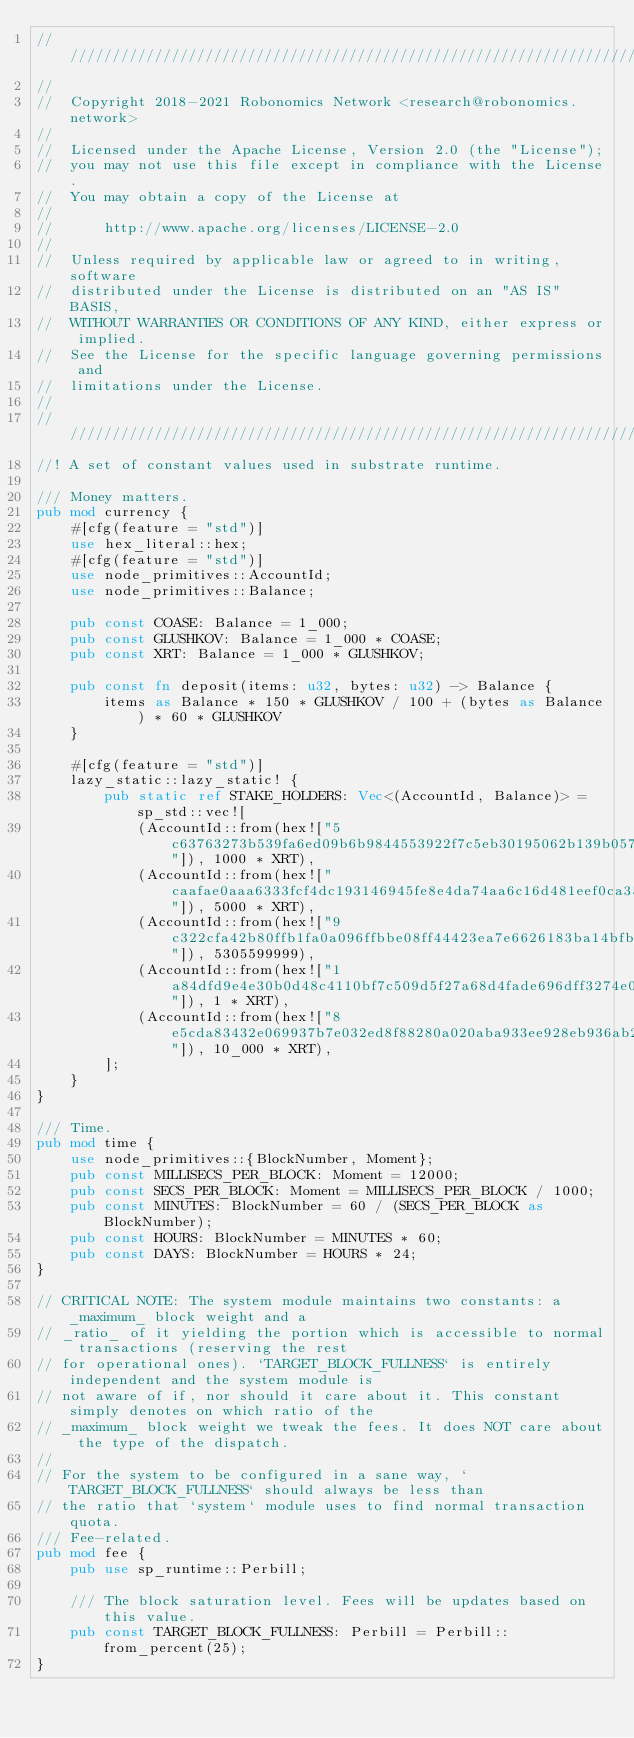Convert code to text. <code><loc_0><loc_0><loc_500><loc_500><_Rust_>///////////////////////////////////////////////////////////////////////////////
//
//  Copyright 2018-2021 Robonomics Network <research@robonomics.network>
//
//  Licensed under the Apache License, Version 2.0 (the "License");
//  you may not use this file except in compliance with the License.
//  You may obtain a copy of the License at
//
//      http://www.apache.org/licenses/LICENSE-2.0
//
//  Unless required by applicable law or agreed to in writing, software
//  distributed under the License is distributed on an "AS IS" BASIS,
//  WITHOUT WARRANTIES OR CONDITIONS OF ANY KIND, either express or implied.
//  See the License for the specific language governing permissions and
//  limitations under the License.
//
///////////////////////////////////////////////////////////////////////////////
//! A set of constant values used in substrate runtime.

/// Money matters.
pub mod currency {
    #[cfg(feature = "std")]
    use hex_literal::hex;
    #[cfg(feature = "std")]
    use node_primitives::AccountId;
    use node_primitives::Balance;

    pub const COASE: Balance = 1_000;
    pub const GLUSHKOV: Balance = 1_000 * COASE;
    pub const XRT: Balance = 1_000 * GLUSHKOV;

    pub const fn deposit(items: u32, bytes: u32) -> Balance {
        items as Balance * 150 * GLUSHKOV / 100 + (bytes as Balance) * 60 * GLUSHKOV
    }

    #[cfg(feature = "std")]
    lazy_static::lazy_static! {
        pub static ref STAKE_HOLDERS: Vec<(AccountId, Balance)> = sp_std::vec![
            (AccountId::from(hex!["5c63763273b539fa6ed09b6b9844553922f7c5eb30195062b139b057ac861568"]), 1000 * XRT),
            (AccountId::from(hex!["caafae0aaa6333fcf4dc193146945fe8e4da74aa6c16d481eef0ca35b8279d73"]), 5000 * XRT),
            (AccountId::from(hex!["9c322cfa42b80ffb1fa0a096ffbbe08ff44423ea7e6626183ba14bfb20c98c53"]), 5305599999),
            (AccountId::from(hex!["1a84dfd9e4e30b0d48c4110bf7c509d5f27a68d4fade696dff3274e0afa09062"]), 1 * XRT),
            (AccountId::from(hex!["8e5cda83432e069937b7e032ed8f88280a020aba933ee928eb936ab265f4c364"]), 10_000 * XRT),
        ];
    }
}

/// Time.
pub mod time {
    use node_primitives::{BlockNumber, Moment};
    pub const MILLISECS_PER_BLOCK: Moment = 12000;
    pub const SECS_PER_BLOCK: Moment = MILLISECS_PER_BLOCK / 1000;
    pub const MINUTES: BlockNumber = 60 / (SECS_PER_BLOCK as BlockNumber);
    pub const HOURS: BlockNumber = MINUTES * 60;
    pub const DAYS: BlockNumber = HOURS * 24;
}

// CRITICAL NOTE: The system module maintains two constants: a _maximum_ block weight and a
// _ratio_ of it yielding the portion which is accessible to normal transactions (reserving the rest
// for operational ones). `TARGET_BLOCK_FULLNESS` is entirely independent and the system module is
// not aware of if, nor should it care about it. This constant simply denotes on which ratio of the
// _maximum_ block weight we tweak the fees. It does NOT care about the type of the dispatch.
//
// For the system to be configured in a sane way, `TARGET_BLOCK_FULLNESS` should always be less than
// the ratio that `system` module uses to find normal transaction quota.
/// Fee-related.
pub mod fee {
    pub use sp_runtime::Perbill;

    /// The block saturation level. Fees will be updates based on this value.
    pub const TARGET_BLOCK_FULLNESS: Perbill = Perbill::from_percent(25);
}
</code> 